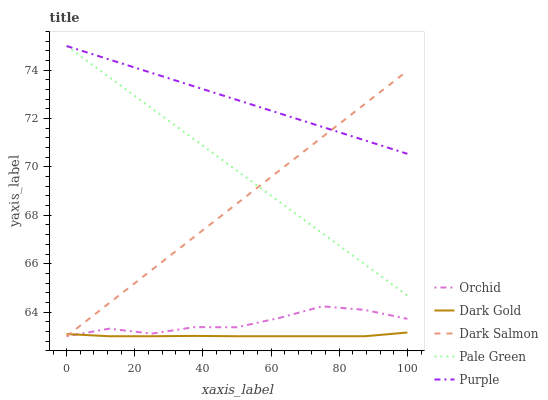Does Pale Green have the minimum area under the curve?
Answer yes or no. No. Does Pale Green have the maximum area under the curve?
Answer yes or no. No. Is Dark Gold the smoothest?
Answer yes or no. No. Is Dark Gold the roughest?
Answer yes or no. No. Does Pale Green have the lowest value?
Answer yes or no. No. Does Dark Gold have the highest value?
Answer yes or no. No. Is Dark Gold less than Purple?
Answer yes or no. Yes. Is Purple greater than Dark Gold?
Answer yes or no. Yes. Does Dark Gold intersect Purple?
Answer yes or no. No. 